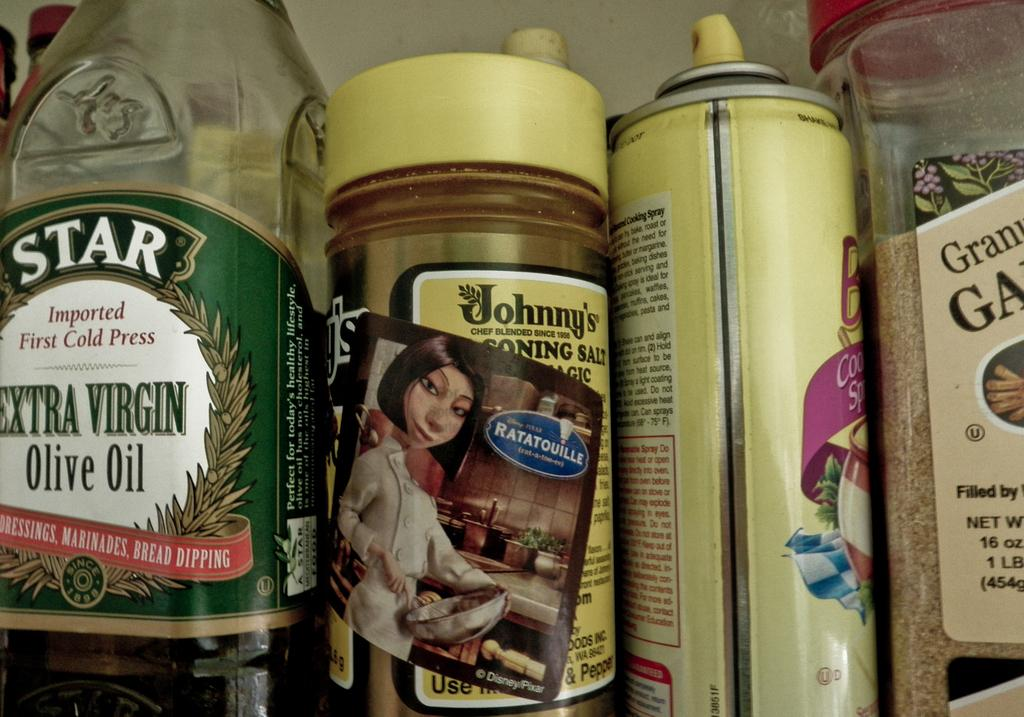Provide a one-sentence caption for the provided image. Several spices and oils in a kitchen, one of which reads EXTRA VIRGIN Olive Oil on the front. 